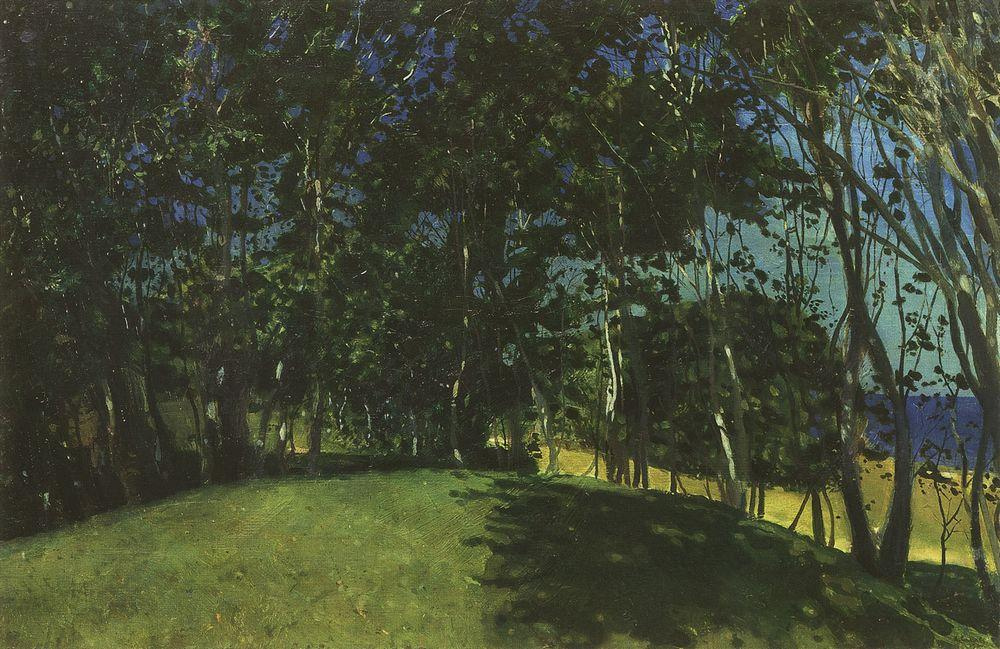What's happening in the scene? This image is a painting that beautifully portrays a tranquil, natural landscape. The style of the artwork is reminiscent of post-impressionism with visible brushstrokes and a rich textural quality that suggests a deep engagement with the natural environment. The composition consists mostly of a dense cluster of trees with a variation of green hues symbolizing the vitality of nature. The blue patches peeking through the canopy could represent either sky or water, adding a contrasting coolness to the warm greens. Dapples of sunlight appear to filter through the leaves, suggesting it may be early morning or late afternoon, times when the sun casts elongated shadows and light plays dynamically through the foliage. This work invites the viewer to contemplate the serene and untouched aspects of nature. 